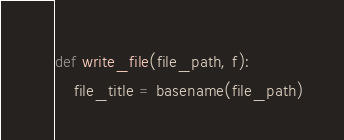<code> <loc_0><loc_0><loc_500><loc_500><_Python_>def write_file(file_path, f):
    file_title = basename(file_path)</code> 